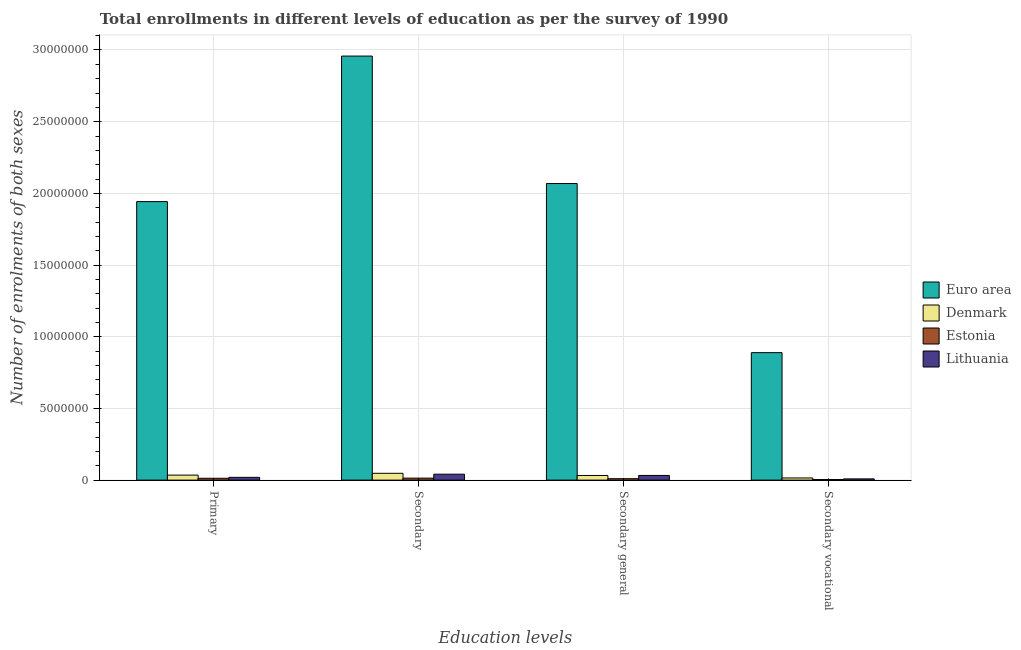How many different coloured bars are there?
Offer a terse response. 4. How many groups of bars are there?
Offer a very short reply. 4. Are the number of bars per tick equal to the number of legend labels?
Offer a very short reply. Yes. Are the number of bars on each tick of the X-axis equal?
Make the answer very short. Yes. What is the label of the 2nd group of bars from the left?
Provide a succinct answer. Secondary. What is the number of enrolments in secondary vocational education in Lithuania?
Offer a terse response. 8.66e+04. Across all countries, what is the maximum number of enrolments in secondary vocational education?
Your answer should be compact. 8.89e+06. Across all countries, what is the minimum number of enrolments in primary education?
Give a very brief answer. 1.28e+05. In which country was the number of enrolments in primary education minimum?
Keep it short and to the point. Estonia. What is the total number of enrolments in secondary vocational education in the graph?
Keep it short and to the point. 9.17e+06. What is the difference between the number of enrolments in secondary vocational education in Estonia and that in Lithuania?
Ensure brevity in your answer.  -4.72e+04. What is the difference between the number of enrolments in primary education in Denmark and the number of enrolments in secondary general education in Estonia?
Provide a succinct answer. 2.51e+05. What is the average number of enrolments in secondary vocational education per country?
Your answer should be compact. 2.29e+06. What is the difference between the number of enrolments in secondary general education and number of enrolments in primary education in Denmark?
Keep it short and to the point. -2.62e+04. In how many countries, is the number of enrolments in secondary education greater than 26000000 ?
Give a very brief answer. 1. What is the ratio of the number of enrolments in secondary vocational education in Euro area to that in Lithuania?
Ensure brevity in your answer.  102.69. Is the number of enrolments in secondary education in Euro area less than that in Lithuania?
Ensure brevity in your answer.  No. Is the difference between the number of enrolments in secondary general education in Denmark and Estonia greater than the difference between the number of enrolments in secondary vocational education in Denmark and Estonia?
Your answer should be compact. Yes. What is the difference between the highest and the second highest number of enrolments in secondary vocational education?
Give a very brief answer. 8.74e+06. What is the difference between the highest and the lowest number of enrolments in secondary vocational education?
Give a very brief answer. 8.85e+06. Is it the case that in every country, the sum of the number of enrolments in secondary general education and number of enrolments in secondary vocational education is greater than the sum of number of enrolments in primary education and number of enrolments in secondary education?
Provide a succinct answer. No. What does the 4th bar from the left in Secondary general represents?
Your answer should be compact. Lithuania. What does the 2nd bar from the right in Secondary vocational represents?
Offer a very short reply. Estonia. How many countries are there in the graph?
Ensure brevity in your answer.  4. Does the graph contain any zero values?
Your response must be concise. No. How many legend labels are there?
Ensure brevity in your answer.  4. What is the title of the graph?
Your response must be concise. Total enrollments in different levels of education as per the survey of 1990. Does "Brazil" appear as one of the legend labels in the graph?
Offer a very short reply. No. What is the label or title of the X-axis?
Your response must be concise. Education levels. What is the label or title of the Y-axis?
Your answer should be very brief. Number of enrolments of both sexes. What is the Number of enrolments of both sexes of Euro area in Primary?
Offer a very short reply. 1.94e+07. What is the Number of enrolments of both sexes in Denmark in Primary?
Offer a terse response. 3.50e+05. What is the Number of enrolments of both sexes in Estonia in Primary?
Provide a succinct answer. 1.28e+05. What is the Number of enrolments of both sexes of Lithuania in Primary?
Provide a succinct answer. 1.93e+05. What is the Number of enrolments of both sexes of Euro area in Secondary?
Provide a short and direct response. 2.96e+07. What is the Number of enrolments of both sexes in Denmark in Secondary?
Your answer should be compact. 4.75e+05. What is the Number of enrolments of both sexes of Estonia in Secondary?
Keep it short and to the point. 1.39e+05. What is the Number of enrolments of both sexes of Lithuania in Secondary?
Provide a short and direct response. 4.13e+05. What is the Number of enrolments of both sexes in Euro area in Secondary general?
Your response must be concise. 2.07e+07. What is the Number of enrolments of both sexes in Denmark in Secondary general?
Provide a short and direct response. 3.24e+05. What is the Number of enrolments of both sexes in Estonia in Secondary general?
Keep it short and to the point. 9.93e+04. What is the Number of enrolments of both sexes of Lithuania in Secondary general?
Provide a short and direct response. 3.26e+05. What is the Number of enrolments of both sexes of Euro area in Secondary vocational?
Make the answer very short. 8.89e+06. What is the Number of enrolments of both sexes of Denmark in Secondary vocational?
Provide a succinct answer. 1.51e+05. What is the Number of enrolments of both sexes in Estonia in Secondary vocational?
Your answer should be very brief. 3.93e+04. What is the Number of enrolments of both sexes in Lithuania in Secondary vocational?
Your answer should be compact. 8.66e+04. Across all Education levels, what is the maximum Number of enrolments of both sexes of Euro area?
Your response must be concise. 2.96e+07. Across all Education levels, what is the maximum Number of enrolments of both sexes of Denmark?
Provide a succinct answer. 4.75e+05. Across all Education levels, what is the maximum Number of enrolments of both sexes in Estonia?
Offer a very short reply. 1.39e+05. Across all Education levels, what is the maximum Number of enrolments of both sexes in Lithuania?
Make the answer very short. 4.13e+05. Across all Education levels, what is the minimum Number of enrolments of both sexes in Euro area?
Provide a short and direct response. 8.89e+06. Across all Education levels, what is the minimum Number of enrolments of both sexes in Denmark?
Make the answer very short. 1.51e+05. Across all Education levels, what is the minimum Number of enrolments of both sexes of Estonia?
Provide a succinct answer. 3.93e+04. Across all Education levels, what is the minimum Number of enrolments of both sexes of Lithuania?
Make the answer very short. 8.66e+04. What is the total Number of enrolments of both sexes of Euro area in the graph?
Offer a very short reply. 7.86e+07. What is the total Number of enrolments of both sexes in Denmark in the graph?
Give a very brief answer. 1.30e+06. What is the total Number of enrolments of both sexes of Estonia in the graph?
Keep it short and to the point. 4.06e+05. What is the total Number of enrolments of both sexes of Lithuania in the graph?
Make the answer very short. 1.02e+06. What is the difference between the Number of enrolments of both sexes in Euro area in Primary and that in Secondary?
Provide a short and direct response. -1.01e+07. What is the difference between the Number of enrolments of both sexes in Denmark in Primary and that in Secondary?
Make the answer very short. -1.25e+05. What is the difference between the Number of enrolments of both sexes of Estonia in Primary and that in Secondary?
Keep it short and to the point. -1.06e+04. What is the difference between the Number of enrolments of both sexes of Lithuania in Primary and that in Secondary?
Keep it short and to the point. -2.19e+05. What is the difference between the Number of enrolments of both sexes in Euro area in Primary and that in Secondary general?
Provide a short and direct response. -1.26e+06. What is the difference between the Number of enrolments of both sexes of Denmark in Primary and that in Secondary general?
Make the answer very short. 2.62e+04. What is the difference between the Number of enrolments of both sexes in Estonia in Primary and that in Secondary general?
Ensure brevity in your answer.  2.88e+04. What is the difference between the Number of enrolments of both sexes of Lithuania in Primary and that in Secondary general?
Keep it short and to the point. -1.33e+05. What is the difference between the Number of enrolments of both sexes in Euro area in Primary and that in Secondary vocational?
Offer a terse response. 1.05e+07. What is the difference between the Number of enrolments of both sexes of Denmark in Primary and that in Secondary vocational?
Provide a short and direct response. 1.99e+05. What is the difference between the Number of enrolments of both sexes in Estonia in Primary and that in Secondary vocational?
Give a very brief answer. 8.88e+04. What is the difference between the Number of enrolments of both sexes of Lithuania in Primary and that in Secondary vocational?
Offer a very short reply. 1.07e+05. What is the difference between the Number of enrolments of both sexes of Euro area in Secondary and that in Secondary general?
Give a very brief answer. 8.89e+06. What is the difference between the Number of enrolments of both sexes in Denmark in Secondary and that in Secondary general?
Your response must be concise. 1.51e+05. What is the difference between the Number of enrolments of both sexes in Estonia in Secondary and that in Secondary general?
Your response must be concise. 3.93e+04. What is the difference between the Number of enrolments of both sexes of Lithuania in Secondary and that in Secondary general?
Your answer should be compact. 8.66e+04. What is the difference between the Number of enrolments of both sexes in Euro area in Secondary and that in Secondary vocational?
Offer a very short reply. 2.07e+07. What is the difference between the Number of enrolments of both sexes in Denmark in Secondary and that in Secondary vocational?
Keep it short and to the point. 3.24e+05. What is the difference between the Number of enrolments of both sexes in Estonia in Secondary and that in Secondary vocational?
Provide a succinct answer. 9.93e+04. What is the difference between the Number of enrolments of both sexes of Lithuania in Secondary and that in Secondary vocational?
Your answer should be very brief. 3.26e+05. What is the difference between the Number of enrolments of both sexes in Euro area in Secondary general and that in Secondary vocational?
Offer a very short reply. 1.18e+07. What is the difference between the Number of enrolments of both sexes of Denmark in Secondary general and that in Secondary vocational?
Your answer should be compact. 1.73e+05. What is the difference between the Number of enrolments of both sexes in Estonia in Secondary general and that in Secondary vocational?
Offer a very short reply. 6.00e+04. What is the difference between the Number of enrolments of both sexes in Lithuania in Secondary general and that in Secondary vocational?
Make the answer very short. 2.40e+05. What is the difference between the Number of enrolments of both sexes in Euro area in Primary and the Number of enrolments of both sexes in Denmark in Secondary?
Your answer should be compact. 1.90e+07. What is the difference between the Number of enrolments of both sexes of Euro area in Primary and the Number of enrolments of both sexes of Estonia in Secondary?
Keep it short and to the point. 1.93e+07. What is the difference between the Number of enrolments of both sexes of Euro area in Primary and the Number of enrolments of both sexes of Lithuania in Secondary?
Ensure brevity in your answer.  1.90e+07. What is the difference between the Number of enrolments of both sexes in Denmark in Primary and the Number of enrolments of both sexes in Estonia in Secondary?
Your answer should be very brief. 2.12e+05. What is the difference between the Number of enrolments of both sexes of Denmark in Primary and the Number of enrolments of both sexes of Lithuania in Secondary?
Make the answer very short. -6.25e+04. What is the difference between the Number of enrolments of both sexes of Estonia in Primary and the Number of enrolments of both sexes of Lithuania in Secondary?
Make the answer very short. -2.85e+05. What is the difference between the Number of enrolments of both sexes in Euro area in Primary and the Number of enrolments of both sexes in Denmark in Secondary general?
Offer a very short reply. 1.91e+07. What is the difference between the Number of enrolments of both sexes of Euro area in Primary and the Number of enrolments of both sexes of Estonia in Secondary general?
Your response must be concise. 1.93e+07. What is the difference between the Number of enrolments of both sexes in Euro area in Primary and the Number of enrolments of both sexes in Lithuania in Secondary general?
Make the answer very short. 1.91e+07. What is the difference between the Number of enrolments of both sexes of Denmark in Primary and the Number of enrolments of both sexes of Estonia in Secondary general?
Make the answer very short. 2.51e+05. What is the difference between the Number of enrolments of both sexes of Denmark in Primary and the Number of enrolments of both sexes of Lithuania in Secondary general?
Provide a short and direct response. 2.41e+04. What is the difference between the Number of enrolments of both sexes of Estonia in Primary and the Number of enrolments of both sexes of Lithuania in Secondary general?
Your answer should be very brief. -1.98e+05. What is the difference between the Number of enrolments of both sexes in Euro area in Primary and the Number of enrolments of both sexes in Denmark in Secondary vocational?
Give a very brief answer. 1.93e+07. What is the difference between the Number of enrolments of both sexes in Euro area in Primary and the Number of enrolments of both sexes in Estonia in Secondary vocational?
Your answer should be very brief. 1.94e+07. What is the difference between the Number of enrolments of both sexes in Euro area in Primary and the Number of enrolments of both sexes in Lithuania in Secondary vocational?
Your answer should be compact. 1.93e+07. What is the difference between the Number of enrolments of both sexes in Denmark in Primary and the Number of enrolments of both sexes in Estonia in Secondary vocational?
Your response must be concise. 3.11e+05. What is the difference between the Number of enrolments of both sexes of Denmark in Primary and the Number of enrolments of both sexes of Lithuania in Secondary vocational?
Your answer should be very brief. 2.64e+05. What is the difference between the Number of enrolments of both sexes in Estonia in Primary and the Number of enrolments of both sexes in Lithuania in Secondary vocational?
Your response must be concise. 4.16e+04. What is the difference between the Number of enrolments of both sexes of Euro area in Secondary and the Number of enrolments of both sexes of Denmark in Secondary general?
Your answer should be compact. 2.93e+07. What is the difference between the Number of enrolments of both sexes of Euro area in Secondary and the Number of enrolments of both sexes of Estonia in Secondary general?
Your answer should be compact. 2.95e+07. What is the difference between the Number of enrolments of both sexes of Euro area in Secondary and the Number of enrolments of both sexes of Lithuania in Secondary general?
Your response must be concise. 2.92e+07. What is the difference between the Number of enrolments of both sexes in Denmark in Secondary and the Number of enrolments of both sexes in Estonia in Secondary general?
Ensure brevity in your answer.  3.76e+05. What is the difference between the Number of enrolments of both sexes of Denmark in Secondary and the Number of enrolments of both sexes of Lithuania in Secondary general?
Provide a succinct answer. 1.49e+05. What is the difference between the Number of enrolments of both sexes of Estonia in Secondary and the Number of enrolments of both sexes of Lithuania in Secondary general?
Provide a short and direct response. -1.87e+05. What is the difference between the Number of enrolments of both sexes of Euro area in Secondary and the Number of enrolments of both sexes of Denmark in Secondary vocational?
Provide a short and direct response. 2.94e+07. What is the difference between the Number of enrolments of both sexes of Euro area in Secondary and the Number of enrolments of both sexes of Estonia in Secondary vocational?
Offer a very short reply. 2.95e+07. What is the difference between the Number of enrolments of both sexes in Euro area in Secondary and the Number of enrolments of both sexes in Lithuania in Secondary vocational?
Ensure brevity in your answer.  2.95e+07. What is the difference between the Number of enrolments of both sexes in Denmark in Secondary and the Number of enrolments of both sexes in Estonia in Secondary vocational?
Your answer should be compact. 4.36e+05. What is the difference between the Number of enrolments of both sexes of Denmark in Secondary and the Number of enrolments of both sexes of Lithuania in Secondary vocational?
Make the answer very short. 3.88e+05. What is the difference between the Number of enrolments of both sexes in Estonia in Secondary and the Number of enrolments of both sexes in Lithuania in Secondary vocational?
Your answer should be very brief. 5.21e+04. What is the difference between the Number of enrolments of both sexes of Euro area in Secondary general and the Number of enrolments of both sexes of Denmark in Secondary vocational?
Your answer should be very brief. 2.05e+07. What is the difference between the Number of enrolments of both sexes in Euro area in Secondary general and the Number of enrolments of both sexes in Estonia in Secondary vocational?
Offer a terse response. 2.06e+07. What is the difference between the Number of enrolments of both sexes in Euro area in Secondary general and the Number of enrolments of both sexes in Lithuania in Secondary vocational?
Provide a succinct answer. 2.06e+07. What is the difference between the Number of enrolments of both sexes of Denmark in Secondary general and the Number of enrolments of both sexes of Estonia in Secondary vocational?
Offer a terse response. 2.85e+05. What is the difference between the Number of enrolments of both sexes in Denmark in Secondary general and the Number of enrolments of both sexes in Lithuania in Secondary vocational?
Your response must be concise. 2.37e+05. What is the difference between the Number of enrolments of both sexes in Estonia in Secondary general and the Number of enrolments of both sexes in Lithuania in Secondary vocational?
Offer a very short reply. 1.28e+04. What is the average Number of enrolments of both sexes in Euro area per Education levels?
Your response must be concise. 1.96e+07. What is the average Number of enrolments of both sexes of Denmark per Education levels?
Your response must be concise. 3.25e+05. What is the average Number of enrolments of both sexes of Estonia per Education levels?
Make the answer very short. 1.01e+05. What is the average Number of enrolments of both sexes of Lithuania per Education levels?
Your response must be concise. 2.55e+05. What is the difference between the Number of enrolments of both sexes in Euro area and Number of enrolments of both sexes in Denmark in Primary?
Offer a terse response. 1.91e+07. What is the difference between the Number of enrolments of both sexes of Euro area and Number of enrolments of both sexes of Estonia in Primary?
Make the answer very short. 1.93e+07. What is the difference between the Number of enrolments of both sexes of Euro area and Number of enrolments of both sexes of Lithuania in Primary?
Your answer should be compact. 1.92e+07. What is the difference between the Number of enrolments of both sexes in Denmark and Number of enrolments of both sexes in Estonia in Primary?
Offer a terse response. 2.22e+05. What is the difference between the Number of enrolments of both sexes in Denmark and Number of enrolments of both sexes in Lithuania in Primary?
Your answer should be very brief. 1.57e+05. What is the difference between the Number of enrolments of both sexes in Estonia and Number of enrolments of both sexes in Lithuania in Primary?
Offer a terse response. -6.53e+04. What is the difference between the Number of enrolments of both sexes in Euro area and Number of enrolments of both sexes in Denmark in Secondary?
Your answer should be compact. 2.91e+07. What is the difference between the Number of enrolments of both sexes of Euro area and Number of enrolments of both sexes of Estonia in Secondary?
Offer a very short reply. 2.94e+07. What is the difference between the Number of enrolments of both sexes of Euro area and Number of enrolments of both sexes of Lithuania in Secondary?
Your answer should be compact. 2.92e+07. What is the difference between the Number of enrolments of both sexes of Denmark and Number of enrolments of both sexes of Estonia in Secondary?
Offer a very short reply. 3.36e+05. What is the difference between the Number of enrolments of both sexes in Denmark and Number of enrolments of both sexes in Lithuania in Secondary?
Provide a succinct answer. 6.22e+04. What is the difference between the Number of enrolments of both sexes of Estonia and Number of enrolments of both sexes of Lithuania in Secondary?
Your answer should be compact. -2.74e+05. What is the difference between the Number of enrolments of both sexes in Euro area and Number of enrolments of both sexes in Denmark in Secondary general?
Make the answer very short. 2.04e+07. What is the difference between the Number of enrolments of both sexes of Euro area and Number of enrolments of both sexes of Estonia in Secondary general?
Make the answer very short. 2.06e+07. What is the difference between the Number of enrolments of both sexes of Euro area and Number of enrolments of both sexes of Lithuania in Secondary general?
Make the answer very short. 2.04e+07. What is the difference between the Number of enrolments of both sexes of Denmark and Number of enrolments of both sexes of Estonia in Secondary general?
Provide a succinct answer. 2.25e+05. What is the difference between the Number of enrolments of both sexes in Denmark and Number of enrolments of both sexes in Lithuania in Secondary general?
Provide a short and direct response. -2076. What is the difference between the Number of enrolments of both sexes in Estonia and Number of enrolments of both sexes in Lithuania in Secondary general?
Give a very brief answer. -2.27e+05. What is the difference between the Number of enrolments of both sexes of Euro area and Number of enrolments of both sexes of Denmark in Secondary vocational?
Make the answer very short. 8.74e+06. What is the difference between the Number of enrolments of both sexes of Euro area and Number of enrolments of both sexes of Estonia in Secondary vocational?
Make the answer very short. 8.85e+06. What is the difference between the Number of enrolments of both sexes of Euro area and Number of enrolments of both sexes of Lithuania in Secondary vocational?
Provide a succinct answer. 8.80e+06. What is the difference between the Number of enrolments of both sexes in Denmark and Number of enrolments of both sexes in Estonia in Secondary vocational?
Provide a short and direct response. 1.12e+05. What is the difference between the Number of enrolments of both sexes in Denmark and Number of enrolments of both sexes in Lithuania in Secondary vocational?
Give a very brief answer. 6.43e+04. What is the difference between the Number of enrolments of both sexes of Estonia and Number of enrolments of both sexes of Lithuania in Secondary vocational?
Give a very brief answer. -4.72e+04. What is the ratio of the Number of enrolments of both sexes in Euro area in Primary to that in Secondary?
Provide a succinct answer. 0.66. What is the ratio of the Number of enrolments of both sexes in Denmark in Primary to that in Secondary?
Provide a short and direct response. 0.74. What is the ratio of the Number of enrolments of both sexes in Estonia in Primary to that in Secondary?
Provide a succinct answer. 0.92. What is the ratio of the Number of enrolments of both sexes in Lithuania in Primary to that in Secondary?
Your answer should be very brief. 0.47. What is the ratio of the Number of enrolments of both sexes of Euro area in Primary to that in Secondary general?
Make the answer very short. 0.94. What is the ratio of the Number of enrolments of both sexes of Denmark in Primary to that in Secondary general?
Your response must be concise. 1.08. What is the ratio of the Number of enrolments of both sexes in Estonia in Primary to that in Secondary general?
Offer a very short reply. 1.29. What is the ratio of the Number of enrolments of both sexes of Lithuania in Primary to that in Secondary general?
Make the answer very short. 0.59. What is the ratio of the Number of enrolments of both sexes of Euro area in Primary to that in Secondary vocational?
Offer a very short reply. 2.19. What is the ratio of the Number of enrolments of both sexes of Denmark in Primary to that in Secondary vocational?
Offer a terse response. 2.32. What is the ratio of the Number of enrolments of both sexes of Estonia in Primary to that in Secondary vocational?
Offer a very short reply. 3.26. What is the ratio of the Number of enrolments of both sexes of Lithuania in Primary to that in Secondary vocational?
Your response must be concise. 2.23. What is the ratio of the Number of enrolments of both sexes in Euro area in Secondary to that in Secondary general?
Offer a very short reply. 1.43. What is the ratio of the Number of enrolments of both sexes in Denmark in Secondary to that in Secondary general?
Ensure brevity in your answer.  1.47. What is the ratio of the Number of enrolments of both sexes in Estonia in Secondary to that in Secondary general?
Ensure brevity in your answer.  1.4. What is the ratio of the Number of enrolments of both sexes of Lithuania in Secondary to that in Secondary general?
Your answer should be compact. 1.27. What is the ratio of the Number of enrolments of both sexes of Euro area in Secondary to that in Secondary vocational?
Your answer should be compact. 3.33. What is the ratio of the Number of enrolments of both sexes in Denmark in Secondary to that in Secondary vocational?
Keep it short and to the point. 3.15. What is the ratio of the Number of enrolments of both sexes of Estonia in Secondary to that in Secondary vocational?
Your answer should be very brief. 3.53. What is the ratio of the Number of enrolments of both sexes of Lithuania in Secondary to that in Secondary vocational?
Your answer should be very brief. 4.77. What is the ratio of the Number of enrolments of both sexes of Euro area in Secondary general to that in Secondary vocational?
Ensure brevity in your answer.  2.33. What is the ratio of the Number of enrolments of both sexes of Denmark in Secondary general to that in Secondary vocational?
Your answer should be compact. 2.15. What is the ratio of the Number of enrolments of both sexes of Estonia in Secondary general to that in Secondary vocational?
Your response must be concise. 2.53. What is the ratio of the Number of enrolments of both sexes of Lithuania in Secondary general to that in Secondary vocational?
Your answer should be compact. 3.77. What is the difference between the highest and the second highest Number of enrolments of both sexes in Euro area?
Make the answer very short. 8.89e+06. What is the difference between the highest and the second highest Number of enrolments of both sexes of Denmark?
Ensure brevity in your answer.  1.25e+05. What is the difference between the highest and the second highest Number of enrolments of both sexes of Estonia?
Your answer should be compact. 1.06e+04. What is the difference between the highest and the second highest Number of enrolments of both sexes of Lithuania?
Offer a very short reply. 8.66e+04. What is the difference between the highest and the lowest Number of enrolments of both sexes in Euro area?
Give a very brief answer. 2.07e+07. What is the difference between the highest and the lowest Number of enrolments of both sexes of Denmark?
Provide a short and direct response. 3.24e+05. What is the difference between the highest and the lowest Number of enrolments of both sexes of Estonia?
Offer a terse response. 9.93e+04. What is the difference between the highest and the lowest Number of enrolments of both sexes of Lithuania?
Make the answer very short. 3.26e+05. 